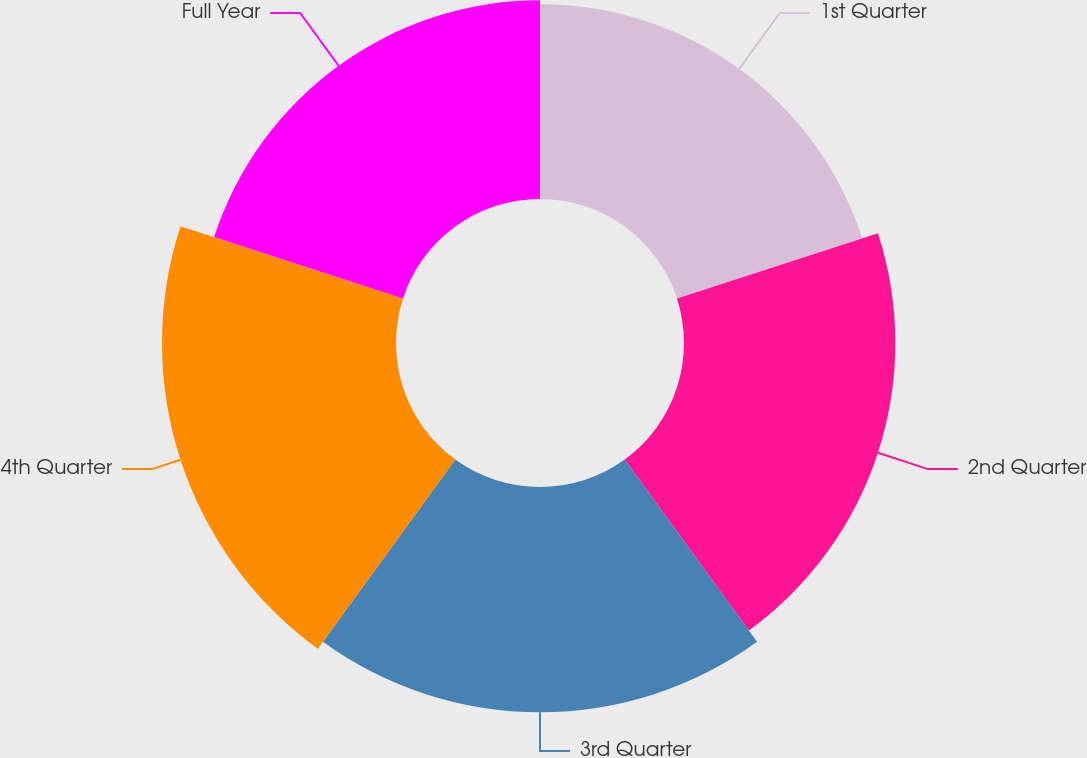Convert chart to OTSL. <chart><loc_0><loc_0><loc_500><loc_500><pie_chart><fcel>1st Quarter<fcel>2nd Quarter<fcel>3rd Quarter<fcel>4th Quarter<fcel>Full Year<nl><fcel>18.31%<fcel>19.86%<fcel>21.17%<fcel>21.99%<fcel>18.67%<nl></chart> 